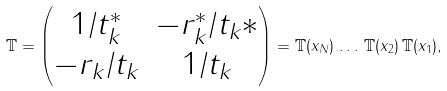<formula> <loc_0><loc_0><loc_500><loc_500>\mathbb { T } = \begin{pmatrix} 1 / t _ { k } ^ { * } & - r _ { k } ^ { * } / t _ { k } * \\ - r _ { k } / t _ { k } & 1 / t _ { k } \end{pmatrix} = \mathbb { T } ( x _ { N } ) \, \dots \, \mathbb { T } ( x _ { 2 } ) \, \mathbb { T } ( x _ { 1 } ) ,</formula> 